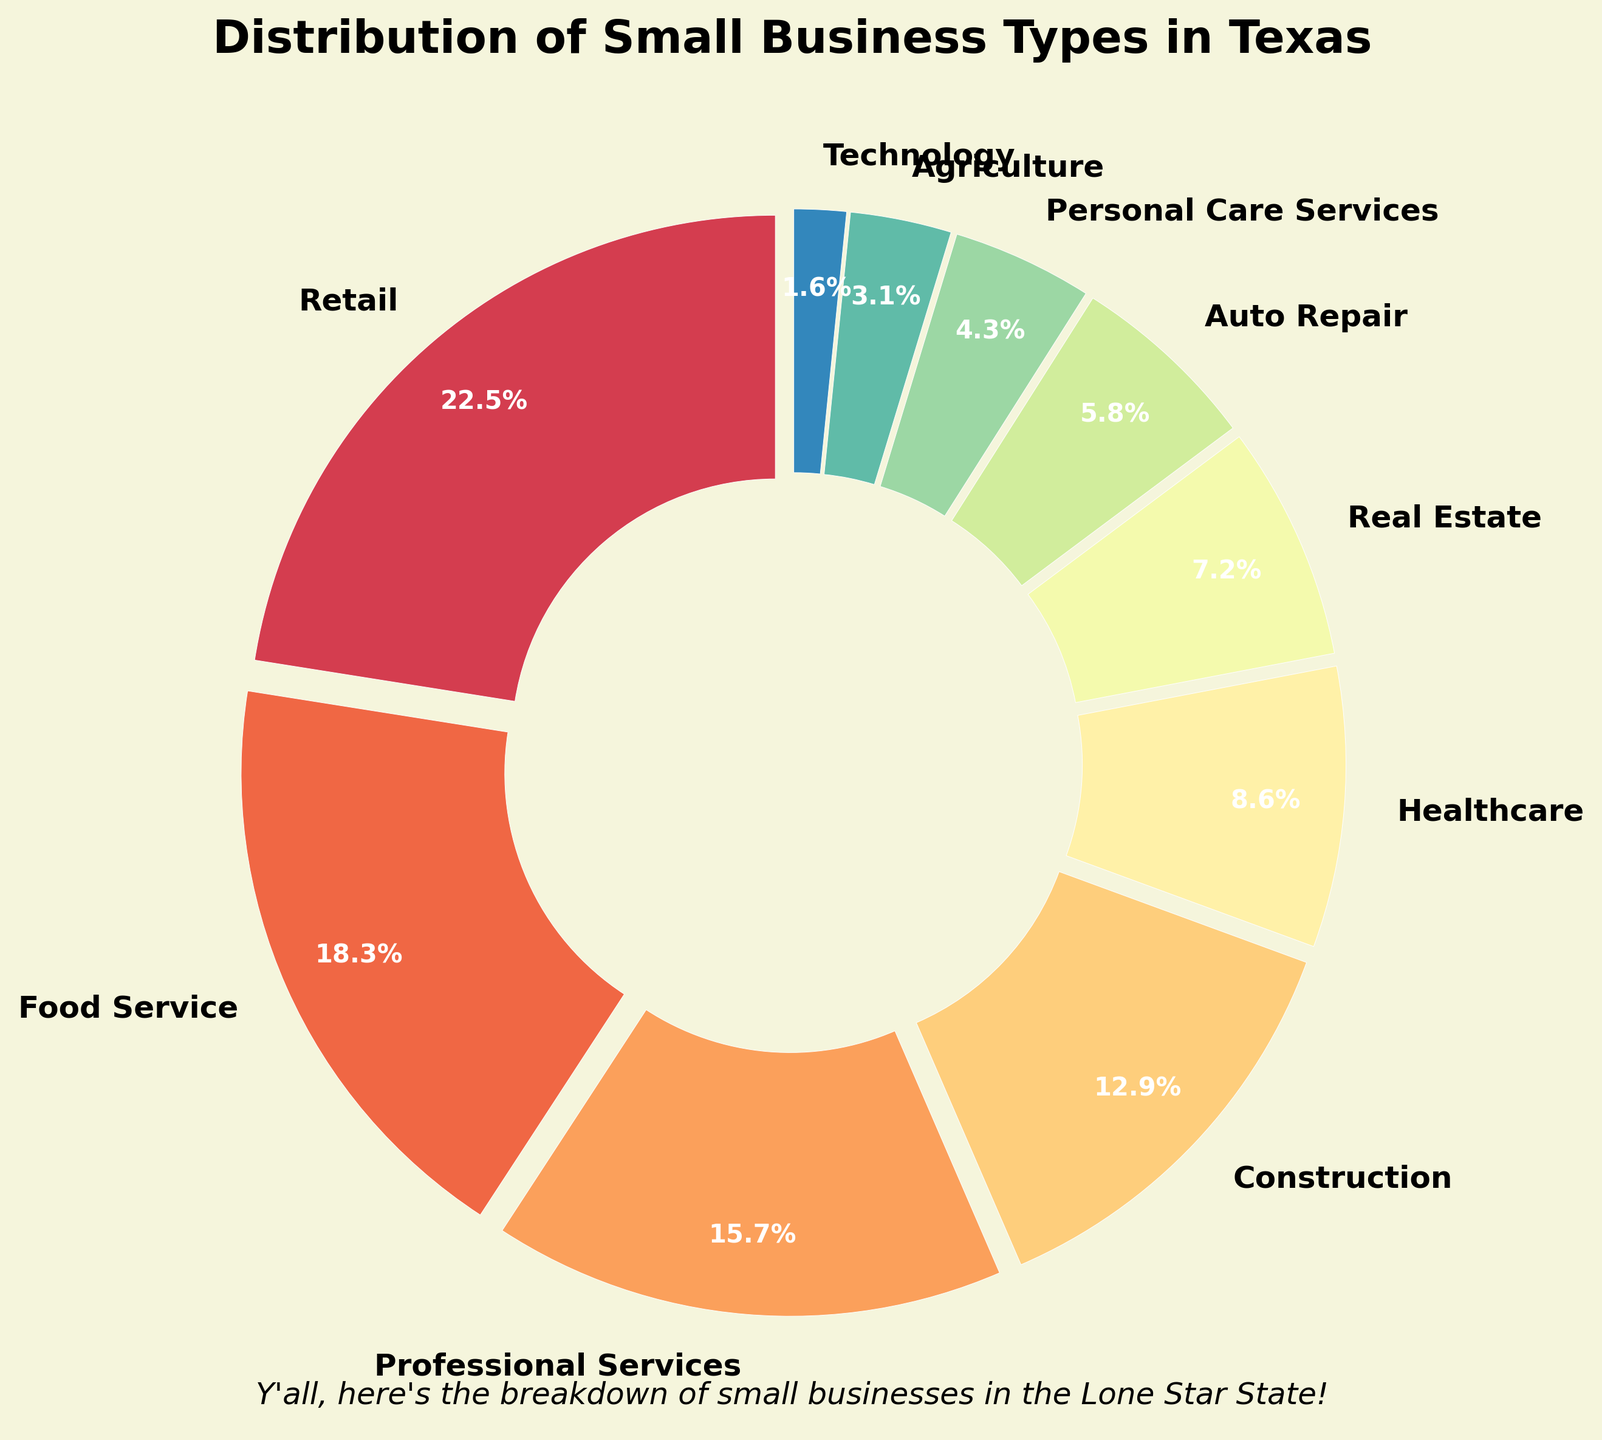What's the largest percentage among all business types? The largest percentage is indicated in the pie chart by the segment with the highest value, which is "Retail" at 22.5%.
Answer: 22.5% Which two business types combined make up the highest percentage? By adding the percentages of different business types, the highest combined percentage is from "Retail" (22.5%) and "Food Service" (18.3%), totaling 40.8%.
Answer: Retail and Food Service How much larger is the percentage of Retail businesses compared to Technology businesses? Subtract the percentage of Technology businesses (1.6%) from the percentage of Retail businesses (22.5%). The difference is 22.5% - 1.6% = 20.9%.
Answer: 20.9% What’s the total percentage of Healthcare, Real Estate, and Auto Repair businesses combined? Add the respective percentages: Healthcare (8.6%) + Real Estate (7.2%) + Auto Repair (5.8%) = 21.6%.
Answer: 21.6% Which business type has a slightly larger percentage: Construction or Professional Services? Compare the percentages directly. Construction is 12.9% and Professional Services is 15.7%.
Answer: Professional Services Is the percentage of Agriculture businesses more than half of Personal Care Services? The percentage of Agriculture (3.1%) and Personal Care Services (4.3%). 3.1% is slightly more than half of 4.3%.
Answer: Yes Which business type has the least visual representation in the pie chart? The smallest segment in the pie chart corresponds to Technology, which is 1.6%.
Answer: Technology If a business falls under either Professional Services or Construction, what's the total likelihood in percentage? Add the percentages of Professional Services (15.7%) and Construction (12.9%) together: 15.7% + 12.9% = 28.6%.
Answer: 28.6% Are the percentages of Real Estate and Auto Repair businesses together more than that of Food Service? Adding Real Estate (7.2%) and Auto Repair (5.8%) gives 13%, which is less than Food Service (18.3%).
Answer: No 